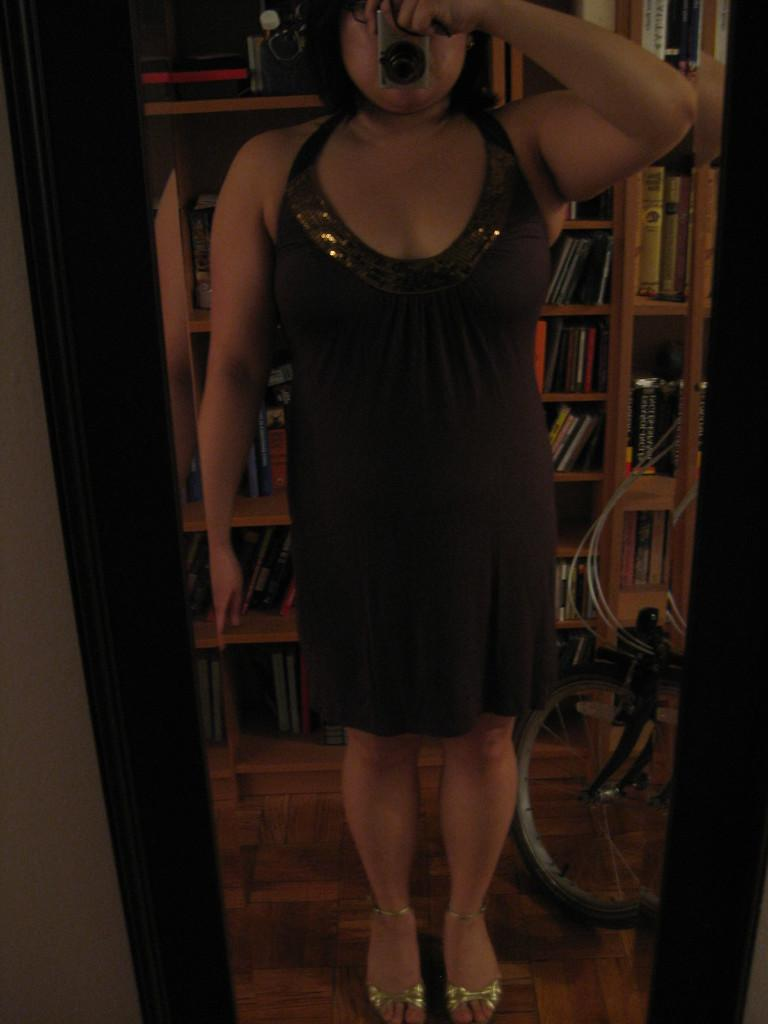What object in the image allows for reflection? There is a mirror in the image. What can be seen in the mirror's reflection? A woman is reflected in the mirror, standing and holding a camera. What other object can be seen in the image? There is a bicycle wheel visible in the image. What type of furniture is present in the image? There is a bookshelf with books in the image. What language is the woman speaking in the image? There is no audio or indication of language in the image, so it cannot be determined. What type of rock is visible in the image? There is no rock present in the image. 